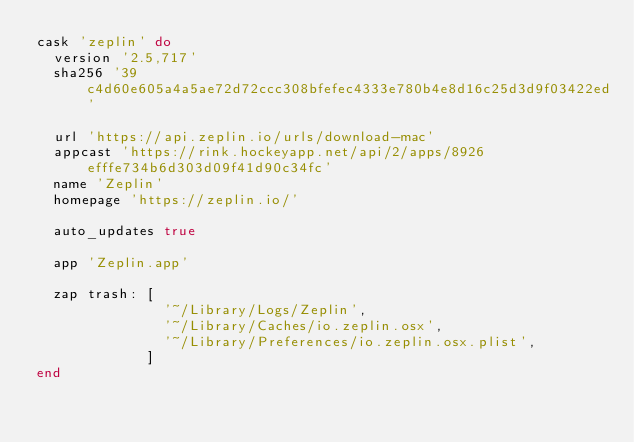<code> <loc_0><loc_0><loc_500><loc_500><_Ruby_>cask 'zeplin' do
  version '2.5,717'
  sha256 '39c4d60e605a4a5ae72d72ccc308bfefec4333e780b4e8d16c25d3d9f03422ed'

  url 'https://api.zeplin.io/urls/download-mac'
  appcast 'https://rink.hockeyapp.net/api/2/apps/8926efffe734b6d303d09f41d90c34fc'
  name 'Zeplin'
  homepage 'https://zeplin.io/'

  auto_updates true

  app 'Zeplin.app'

  zap trash: [
               '~/Library/Logs/Zeplin',
               '~/Library/Caches/io.zeplin.osx',
               '~/Library/Preferences/io.zeplin.osx.plist',
             ]
end
</code> 